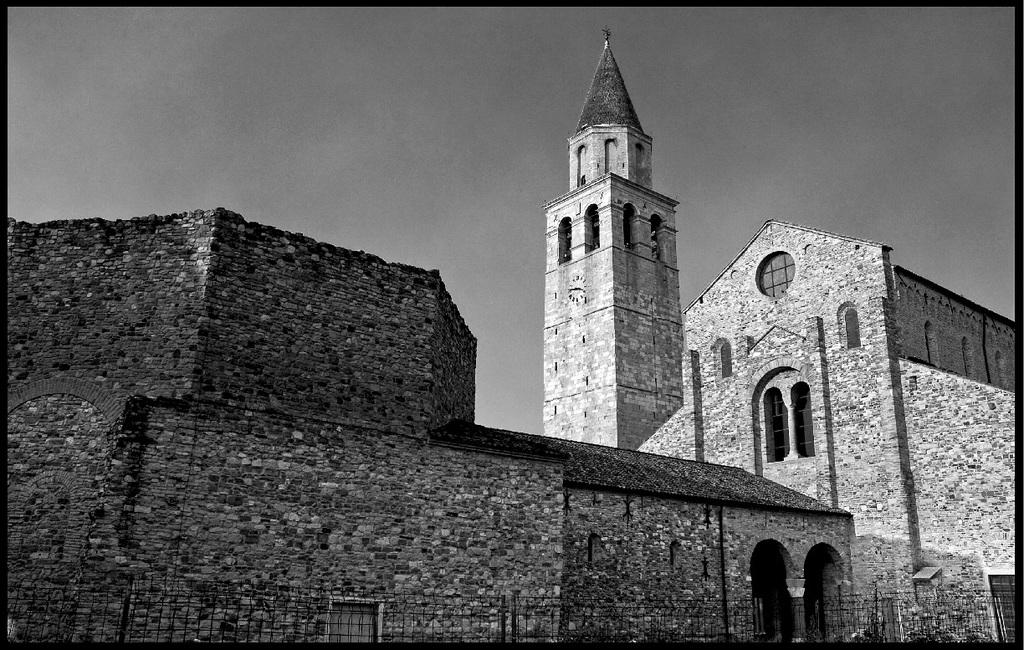What type of structure is in the image? There is a fort in the image. What features does the fort have? The fort has doors and windows. What is the condition of the sky in the image? The sky is clear in the image. What color scheme is used in the image? A: The image is in black and white color. How many eyes can be seen on the fort in the image? There are no eyes visible on the fort in the image, as it is a structure and not a living being. 